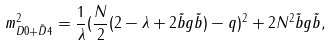Convert formula to latex. <formula><loc_0><loc_0><loc_500><loc_500>m _ { D 0 + \tilde { D } 4 } ^ { 2 } = \frac { 1 } { \lambda } ( \frac { N } { 2 } ( 2 - \lambda + 2 \tilde { b } g \tilde { b } ) - q ) ^ { 2 } + 2 N ^ { 2 } \tilde { b } g \tilde { b } ,</formula> 